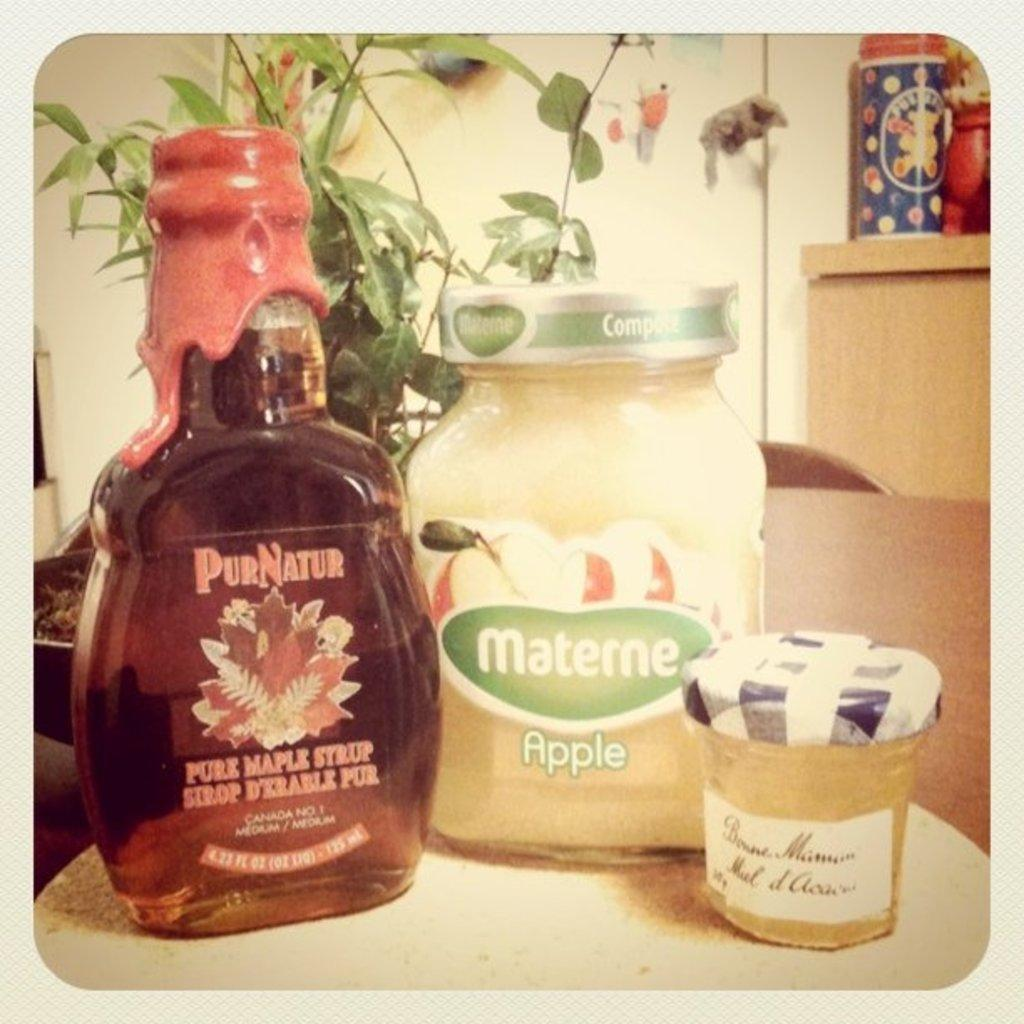<image>
Render a clear and concise summary of the photo. A jar of maple syrup sits next to a jar of apple sauce. 